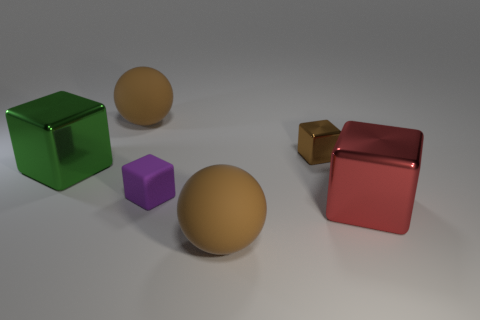Is the number of small shiny things to the right of the brown metallic thing less than the number of things in front of the large green metal cube?
Your answer should be compact. Yes. Are the red object and the purple thing made of the same material?
Make the answer very short. No. There is a block that is on the right side of the green object and to the left of the tiny metal thing; what size is it?
Ensure brevity in your answer.  Small. There is a purple object that is the same size as the brown metallic thing; what shape is it?
Ensure brevity in your answer.  Cube. What is the material of the big brown thing that is behind the large shiny cube on the left side of the big rubber sphere that is in front of the green shiny object?
Ensure brevity in your answer.  Rubber. Do the brown rubber object behind the small purple thing and the large brown thing in front of the brown cube have the same shape?
Offer a terse response. Yes. How many other things are there of the same material as the red object?
Provide a short and direct response. 2. Are the brown sphere behind the brown metal object and the brown thing that is in front of the red metal block made of the same material?
Keep it short and to the point. Yes. What shape is the brown thing that is made of the same material as the large red block?
Ensure brevity in your answer.  Cube. Are there any other things of the same color as the tiny metal cube?
Your response must be concise. Yes. 